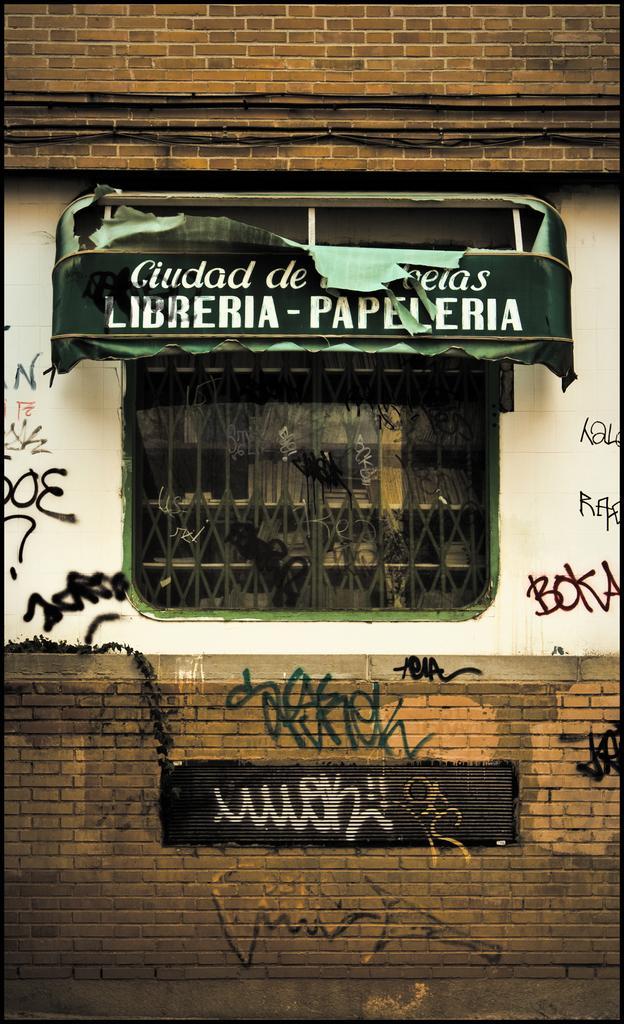Can you describe this image briefly? In the foreground of the picture there is a building's wall. In the center of the picture it is window. At the bottom it is a brick wall, on the wall there is text. In the center of the picture there is a boat. At the top it is brick wall. 